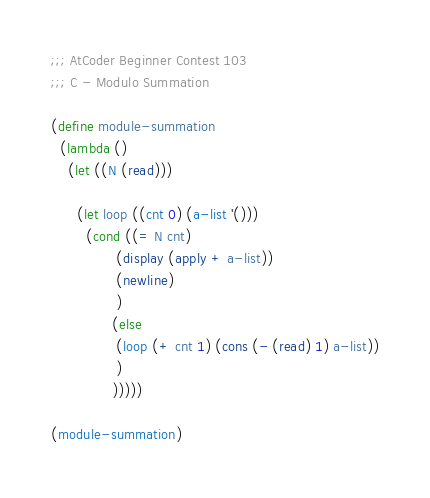<code> <loc_0><loc_0><loc_500><loc_500><_Scheme_>;;; AtCoder Beginner Contest 103
;;; C - Modulo Summation

(define module-summation
  (lambda ()
    (let ((N (read)))

      (let loop ((cnt 0) (a-list '()))
        (cond ((= N cnt)
               (display (apply + a-list))
               (newline)
               )
              (else
               (loop (+ cnt 1) (cons (- (read) 1) a-list))
               )
              )))))

(module-summation)
</code> 